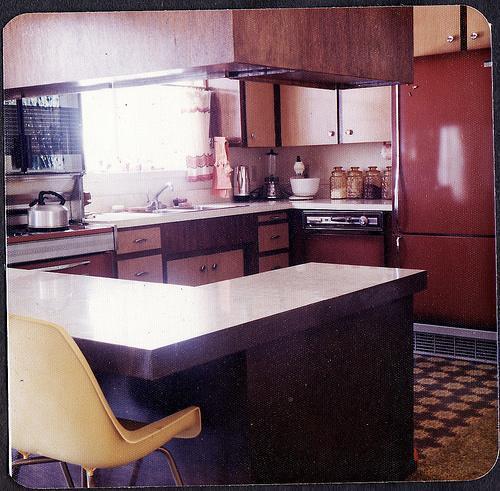What are the jars on the counter?
From the following set of four choices, select the accurate answer to respond to the question.
Options: Gourds, cookie jar, crocks, canisters. Canisters. 